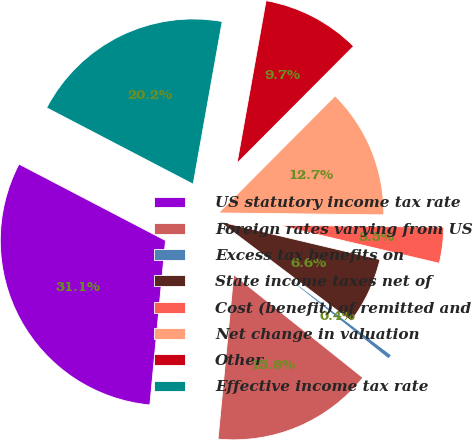<chart> <loc_0><loc_0><loc_500><loc_500><pie_chart><fcel>US statutory income tax rate<fcel>Foreign rates varying from US<fcel>Excess tax benefits on<fcel>State income taxes net of<fcel>Cost (benefit) of remitted and<fcel>Net change in valuation<fcel>Other<fcel>Effective income tax rate<nl><fcel>31.13%<fcel>15.79%<fcel>0.44%<fcel>6.58%<fcel>3.51%<fcel>12.72%<fcel>9.65%<fcel>20.16%<nl></chart> 